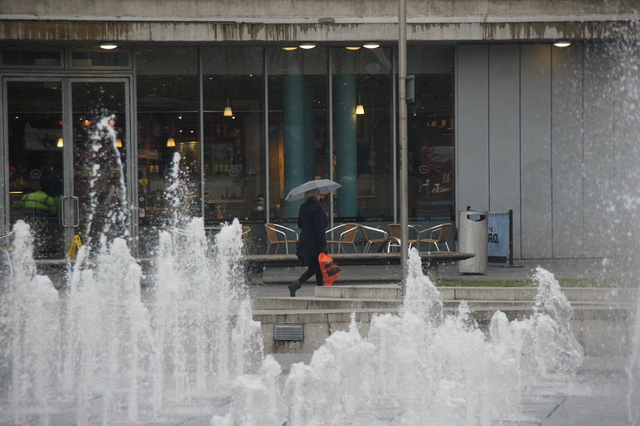Identify the text displayed in this image. RQ 